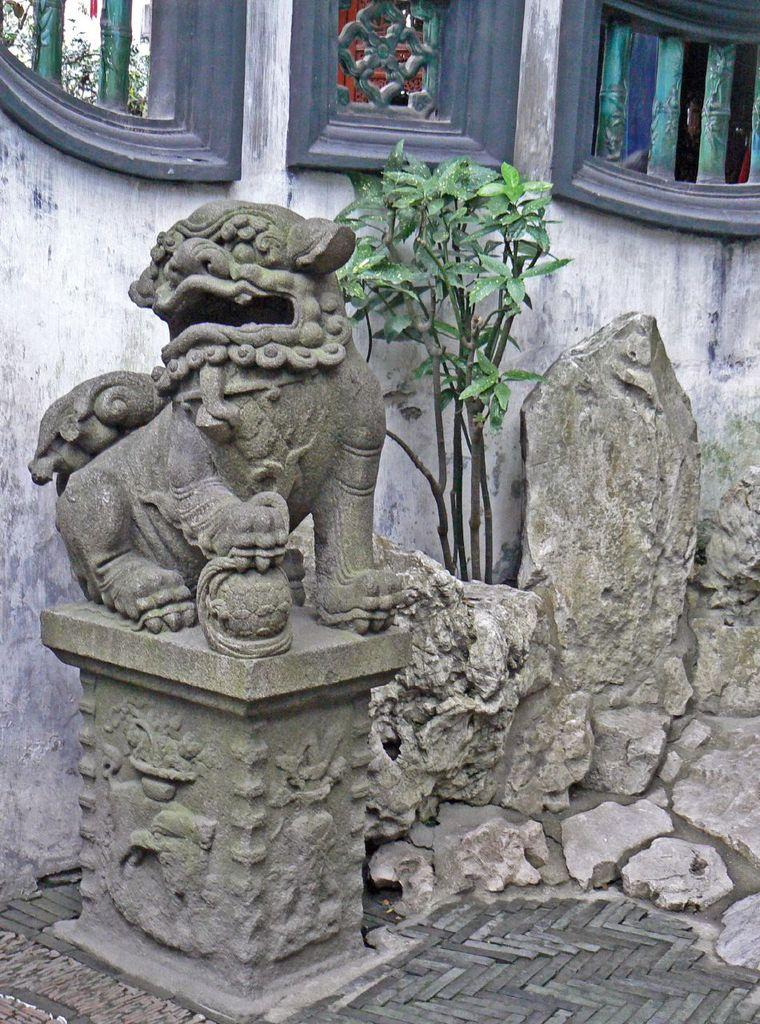What is the main subject in the image? There is a statue on a stand in the image. What can be seen near the statue? There are rocks near the statue. Are there any plants visible in the image? Yes, there is a plant in the image. What is visible in the background of the image? There is a wall with windows in the background of the image. Can you see a pig playing with a match near the statue in the image? No, there is no pig or match present in the image. 